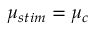Convert formula to latex. <formula><loc_0><loc_0><loc_500><loc_500>\mu _ { s t i m } = \mu _ { c }</formula> 